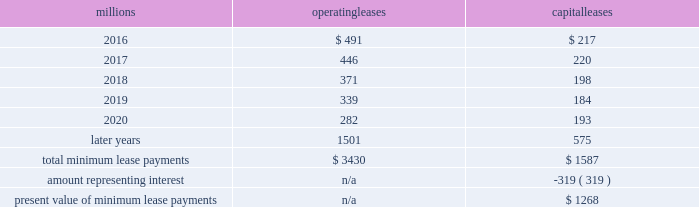We maintain and operate the assets based on contractual obligations within the lease arrangements , which set specific guidelines consistent within the railroad industry .
As such , we have no control over activities that could materially impact the fair value of the leased assets .
We do not hold the power to direct the activities of the vies and , therefore , do not control the ongoing activities that have a significant impact on the economic performance of the vies .
Additionally , we do not have the obligation to absorb losses of the vies or the right to receive benefits of the vies that could potentially be significant to the we are not considered to be the primary beneficiary and do not consolidate these vies because our actions and decisions do not have the most significant effect on the vie 2019s performance and our fixed-price purchase options are not considered to be potentially significant to the vies .
The future minimum lease payments associated with the vie leases totaled $ 2.6 billion as of december 31 , 2015 .
17 .
Leases we lease certain locomotives , freight cars , and other property .
The consolidated statements of financial position as of december 31 , 2015 and 2014 included $ 2273 million , net of $ 1189 million of accumulated depreciation , and $ 2454 million , net of $ 1210 million of accumulated depreciation , respectively , for properties held under capital leases .
A charge to income resulting from the depreciation for assets held under capital leases is included within depreciation expense in our consolidated statements of income .
Future minimum lease payments for operating and capital leases with initial or remaining non-cancelable lease terms in excess of one year as of december 31 , 2015 , were as follows : millions operating leases capital leases .
Approximately 95% ( 95 % ) of capital lease payments relate to locomotives .
Rent expense for operating leases with terms exceeding one month was $ 590 million in 2015 , $ 593 million in 2014 , and $ 618 million in 2013 .
When cash rental payments are not made on a straight-line basis , we recognize variable rental expense on a straight-line basis over the lease term .
Contingent rentals and sub-rentals are not significant .
18 .
Commitments and contingencies asserted and unasserted claims 2013 various claims and lawsuits are pending against us and certain of our subsidiaries .
We cannot fully determine the effect of all asserted and unasserted claims on our consolidated results of operations , financial condition , or liquidity .
To the extent possible , we have recorded a liability where asserted and unasserted claims are considered probable and where such claims can be reasonably estimated .
We do not expect that any known lawsuits , claims , environmental costs , commitments , contingent liabilities , or guarantees will have a material adverse effect on our consolidated results of operations , financial condition , or liquidity after taking into account liabilities and insurance recoveries previously recorded for these matters .
Personal injury 2013 the cost of personal injuries to employees and others related to our activities is charged to expense based on estimates of the ultimate cost and number of incidents each year .
We use an actuarial analysis to measure the expense and liability , including unasserted claims .
The federal employers 2019 liability act ( fela ) governs compensation for work-related accidents .
Under fela , damages are assessed based on a finding of fault through litigation or out-of-court settlements .
We offer a comprehensive variety of services and rehabilitation programs for employees who are injured at work .
Our personal injury liability is not discounted to present value due to the uncertainty surrounding the timing of future payments .
Approximately 94% ( 94 % ) of the recorded liability is related to asserted claims and .
As of december 31 , 2015 what was the percent of the total minimum lease payments that was due in 2016? 
Computations: ((491 + 217) / (3430 + 1587))
Answer: 0.14112. 